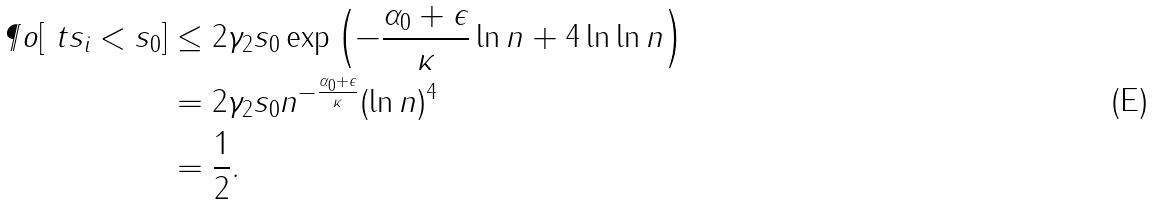<formula> <loc_0><loc_0><loc_500><loc_500>\P o [ \ t s _ { i } < s _ { 0 } ] & \leq 2 { \gamma } _ { 2 } s _ { 0 } \exp \left ( - \frac { \alpha _ { 0 } + \epsilon } { \kappa } \ln n + 4 \ln \ln n \right ) \\ & = 2 { \gamma } _ { 2 } s _ { 0 } n ^ { - \frac { \alpha _ { 0 } + \epsilon } { \kappa } } ( \ln n ) ^ { 4 } \\ & = \frac { 1 } { 2 } .</formula> 